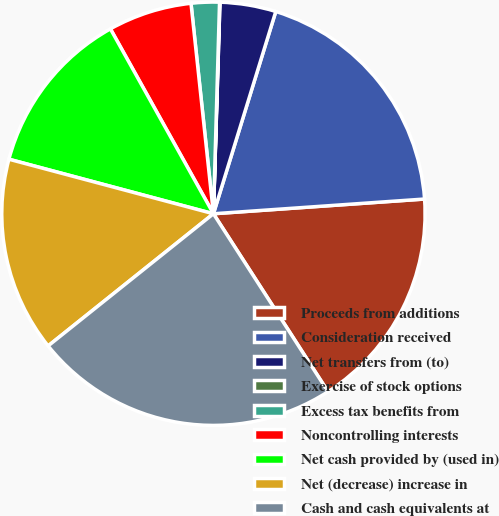<chart> <loc_0><loc_0><loc_500><loc_500><pie_chart><fcel>Proceeds from additions<fcel>Consideration received<fcel>Net transfers from (to)<fcel>Exercise of stock options<fcel>Excess tax benefits from<fcel>Noncontrolling interests<fcel>Net cash provided by (used in)<fcel>Net (decrease) increase in<fcel>Cash and cash equivalents at<nl><fcel>17.0%<fcel>19.13%<fcel>4.27%<fcel>0.03%<fcel>2.15%<fcel>6.4%<fcel>12.76%<fcel>14.88%<fcel>23.37%<nl></chart> 